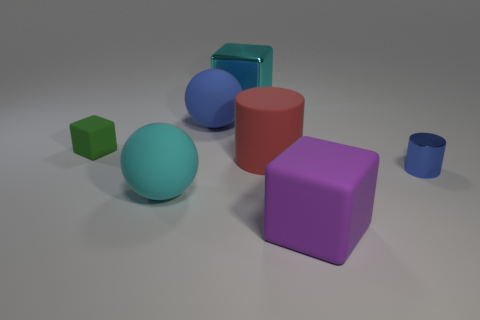There is a thing that is in front of the small metal cylinder and on the left side of the blue rubber object; what material is it made of?
Keep it short and to the point. Rubber. What number of matte things are behind the blue metallic cylinder and to the right of the large red rubber object?
Provide a short and direct response. 0. What is the big purple object made of?
Your response must be concise. Rubber. Are there an equal number of large matte things that are to the left of the large red object and big cyan objects?
Your answer should be compact. Yes. What number of big cyan objects have the same shape as the big red object?
Keep it short and to the point. 0. Do the purple thing and the cyan metallic thing have the same shape?
Keep it short and to the point. Yes. What number of objects are tiny things that are on the right side of the big cyan rubber object or small brown shiny cubes?
Offer a very short reply. 1. What shape is the small thing that is on the right side of the cube in front of the big cyan object that is to the left of the big blue ball?
Provide a succinct answer. Cylinder. What shape is the big purple thing that is made of the same material as the green object?
Your response must be concise. Cube. What is the size of the red object?
Keep it short and to the point. Large. 